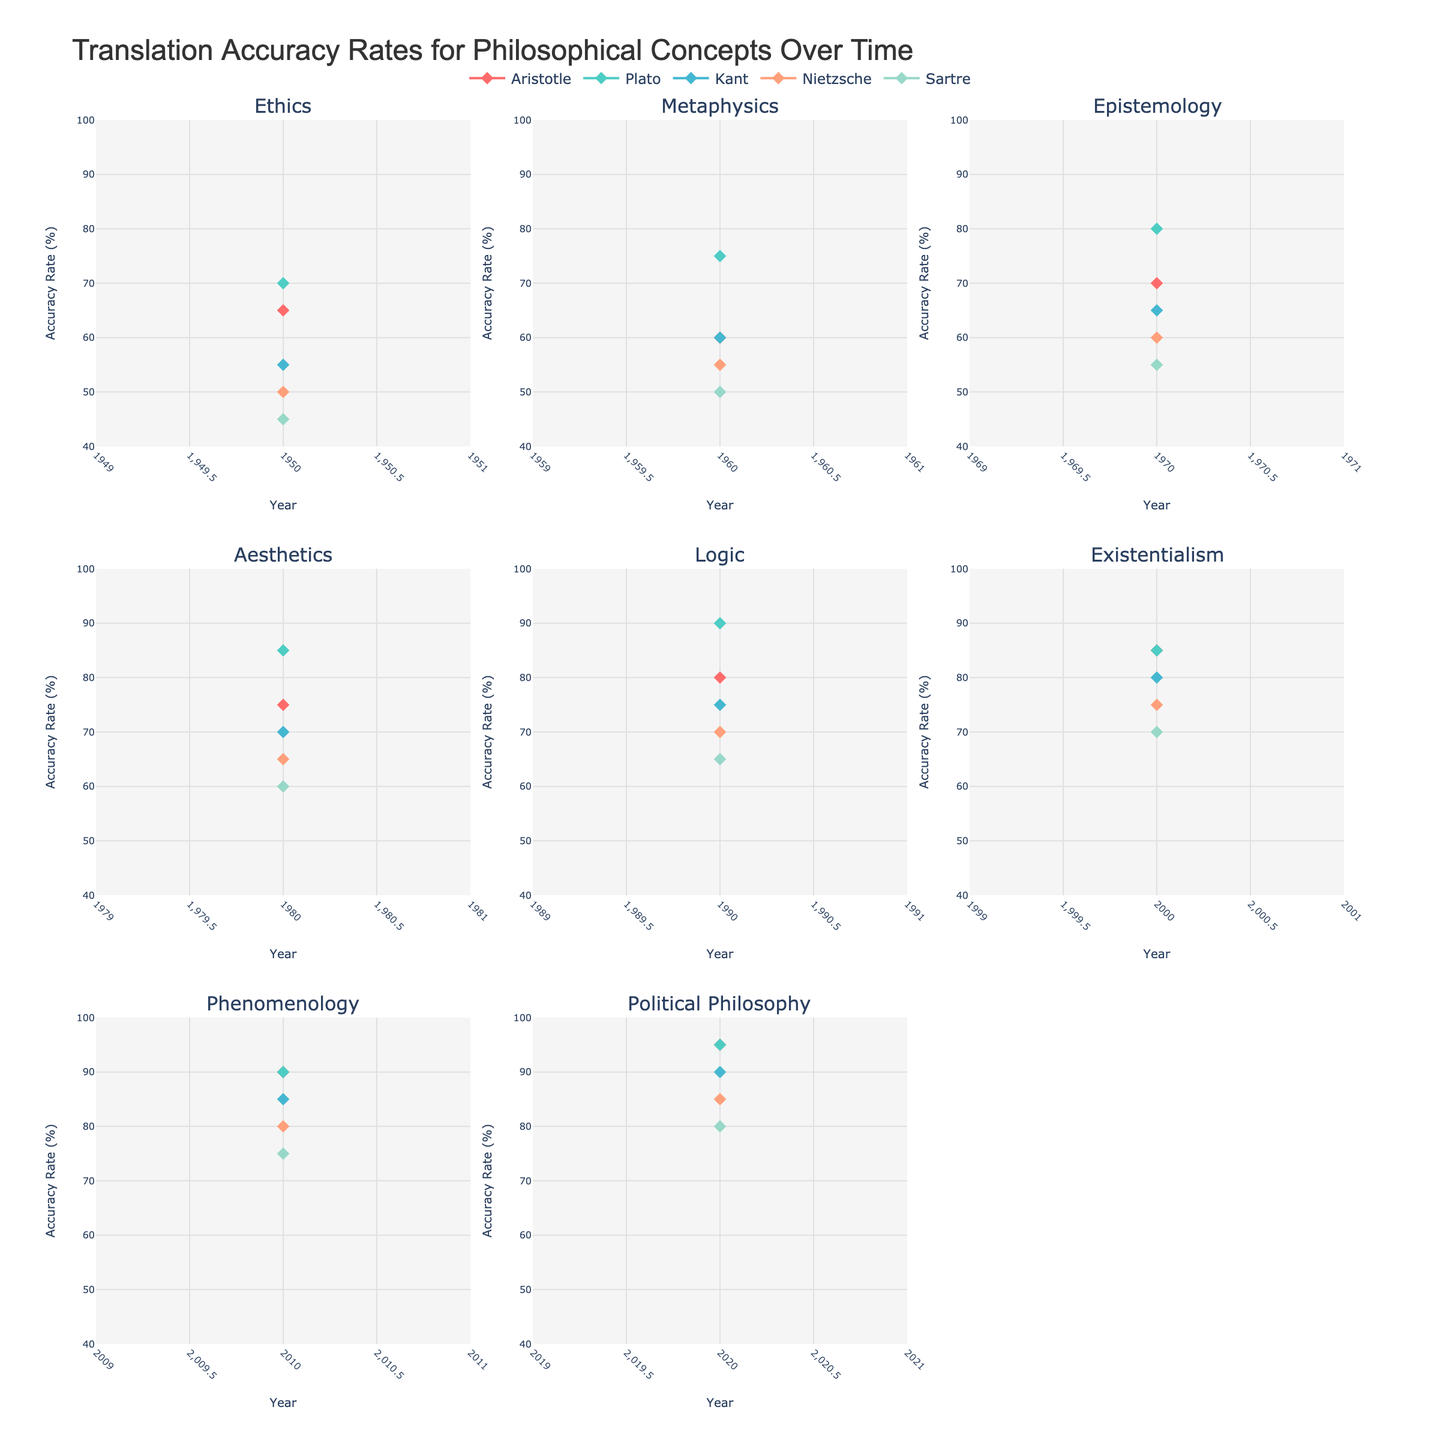What is the title of the figure? The title is the text displayed prominently at the top of the figure. It summarizes what the figure is about. In this case, it reads "Translation Accuracy Rates for Philosophical Concepts Over Time."
Answer: Translation Accuracy Rates for Philosophical Concepts Over Time How many concepts are displayed in the figure? The figure shows subplots for each philosophical concept. Counting these subplots, we see there are eight in total.
Answer: 8 Which philosopher has the highest translation accuracy rate in the year 2020? By looking at the data points for the year 2020 in each subplot and comparing the y-values, we see that Plato and Aristotle both have the highest accuracy rate of 95% for Political Philosophy.
Answer: Aristotle and Plato For the concept of Epistemology, how much did Kant’s translation accuracy improve from 1970 to 1980? We look at Kant's accuracy rate in the Epistemology subplot for 1970 and 1980. In 1970, it was 65%, and in 1980, it was 70%. The improvement is 70% - 65% = 5%.
Answer: 5% Which concept in the figure shows the most improvement in translation accuracy rates over time for Sartre? To find this, we look at Sartre’s data points in each subplot and observe the changes over time. The greatest improvement is seen in Political Philosophy, where it increases from 45% in 1950 to 80% in 2020, an improvement of 35 percentage points.
Answer: Political Philosophy What is the average translation accuracy rate for Nietzsche across all concepts in 1980? We sum Nietzsche's accuracy rates for all concepts in 1980 and divide by the number of concepts. His rates are 50, 55, 60, 65, and 70 respectively, totaling 300. The average is 300 / 5 = 60%.
Answer: 60% Which philosopher had the least improvement in translation accuracy over the given period? To determine this, we compare the first and last data points for each philosopher across all concepts and find the one with the smallest change. Sartre shows the smallest improvement from 45% in 1950 to 80% in 2020, a change of 35%.
Answer: Sartre Between 1950 and 2020, which philosophical concept saw the highest overall accuracy increase across all philosophers? By examining each concept subplot and summing the improvement for each philosopher, Measurement across the time span, Political Philosophy shows the highest collective increase in accuracy.
Answer: Political Philosophy 